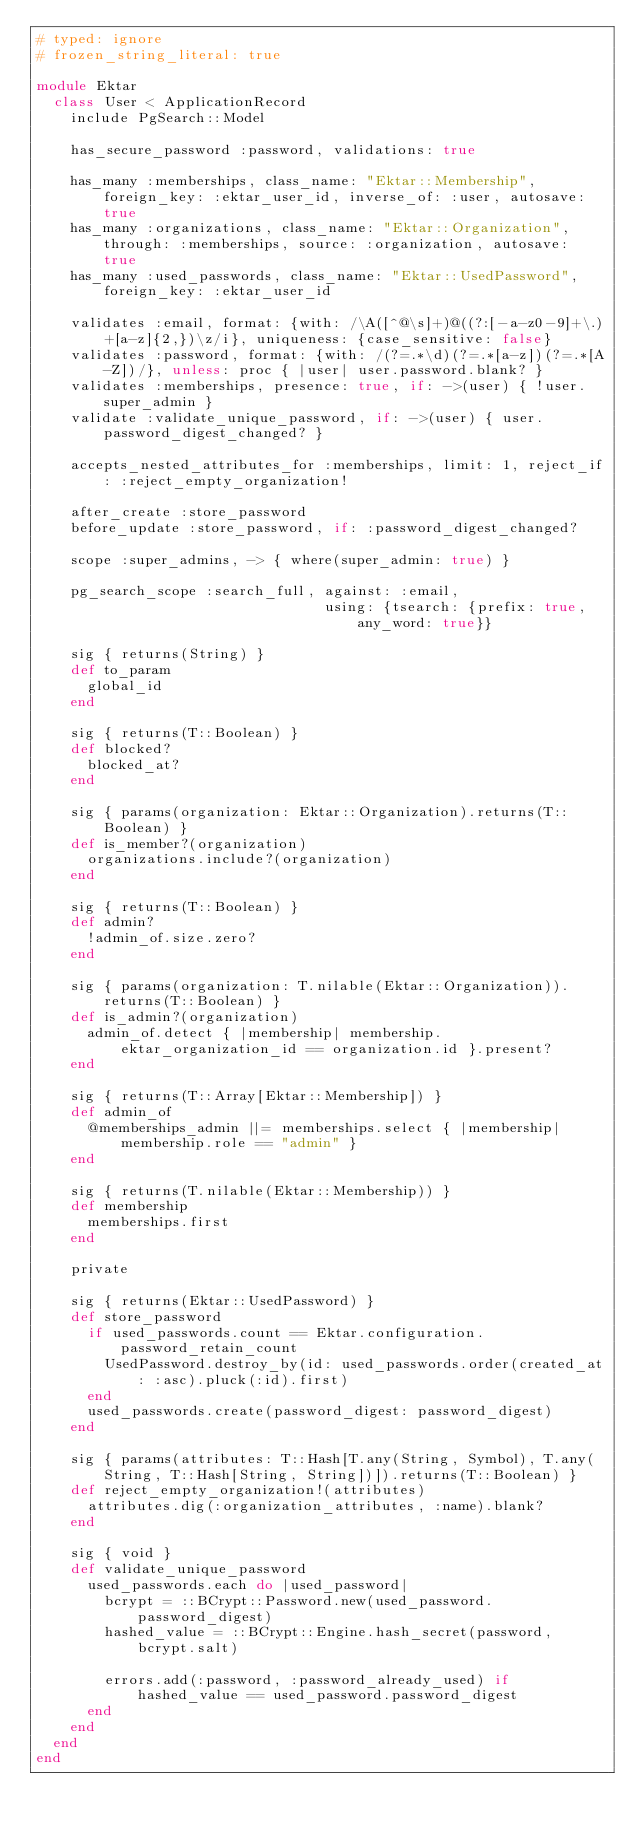Convert code to text. <code><loc_0><loc_0><loc_500><loc_500><_Ruby_># typed: ignore
# frozen_string_literal: true

module Ektar
  class User < ApplicationRecord
    include PgSearch::Model

    has_secure_password :password, validations: true

    has_many :memberships, class_name: "Ektar::Membership", foreign_key: :ektar_user_id, inverse_of: :user, autosave: true
    has_many :organizations, class_name: "Ektar::Organization", through: :memberships, source: :organization, autosave: true
    has_many :used_passwords, class_name: "Ektar::UsedPassword", foreign_key: :ektar_user_id

    validates :email, format: {with: /\A([^@\s]+)@((?:[-a-z0-9]+\.)+[a-z]{2,})\z/i}, uniqueness: {case_sensitive: false}
    validates :password, format: {with: /(?=.*\d)(?=.*[a-z])(?=.*[A-Z])/}, unless: proc { |user| user.password.blank? }
    validates :memberships, presence: true, if: ->(user) { !user.super_admin }
    validate :validate_unique_password, if: ->(user) { user.password_digest_changed? }

    accepts_nested_attributes_for :memberships, limit: 1, reject_if: :reject_empty_organization!

    after_create :store_password
    before_update :store_password, if: :password_digest_changed?

    scope :super_admins, -> { where(super_admin: true) }

    pg_search_scope :search_full, against: :email,
                                  using: {tsearch: {prefix: true, any_word: true}}

    sig { returns(String) }
    def to_param
      global_id
    end

    sig { returns(T::Boolean) }
    def blocked?
      blocked_at?
    end

    sig { params(organization: Ektar::Organization).returns(T::Boolean) }
    def is_member?(organization)
      organizations.include?(organization)
    end

    sig { returns(T::Boolean) }
    def admin?
      !admin_of.size.zero?
    end

    sig { params(organization: T.nilable(Ektar::Organization)).returns(T::Boolean) }
    def is_admin?(organization)
      admin_of.detect { |membership| membership.ektar_organization_id == organization.id }.present?
    end

    sig { returns(T::Array[Ektar::Membership]) }
    def admin_of
      @memberships_admin ||= memberships.select { |membership| membership.role == "admin" }
    end

    sig { returns(T.nilable(Ektar::Membership)) }
    def membership
      memberships.first
    end

    private

    sig { returns(Ektar::UsedPassword) }
    def store_password
      if used_passwords.count == Ektar.configuration.password_retain_count
        UsedPassword.destroy_by(id: used_passwords.order(created_at: :asc).pluck(:id).first)
      end
      used_passwords.create(password_digest: password_digest)
    end

    sig { params(attributes: T::Hash[T.any(String, Symbol), T.any(String, T::Hash[String, String])]).returns(T::Boolean) }
    def reject_empty_organization!(attributes)
      attributes.dig(:organization_attributes, :name).blank?
    end

    sig { void }
    def validate_unique_password
      used_passwords.each do |used_password|
        bcrypt = ::BCrypt::Password.new(used_password.password_digest)
        hashed_value = ::BCrypt::Engine.hash_secret(password, bcrypt.salt)

        errors.add(:password, :password_already_used) if hashed_value == used_password.password_digest
      end
    end
  end
end
</code> 